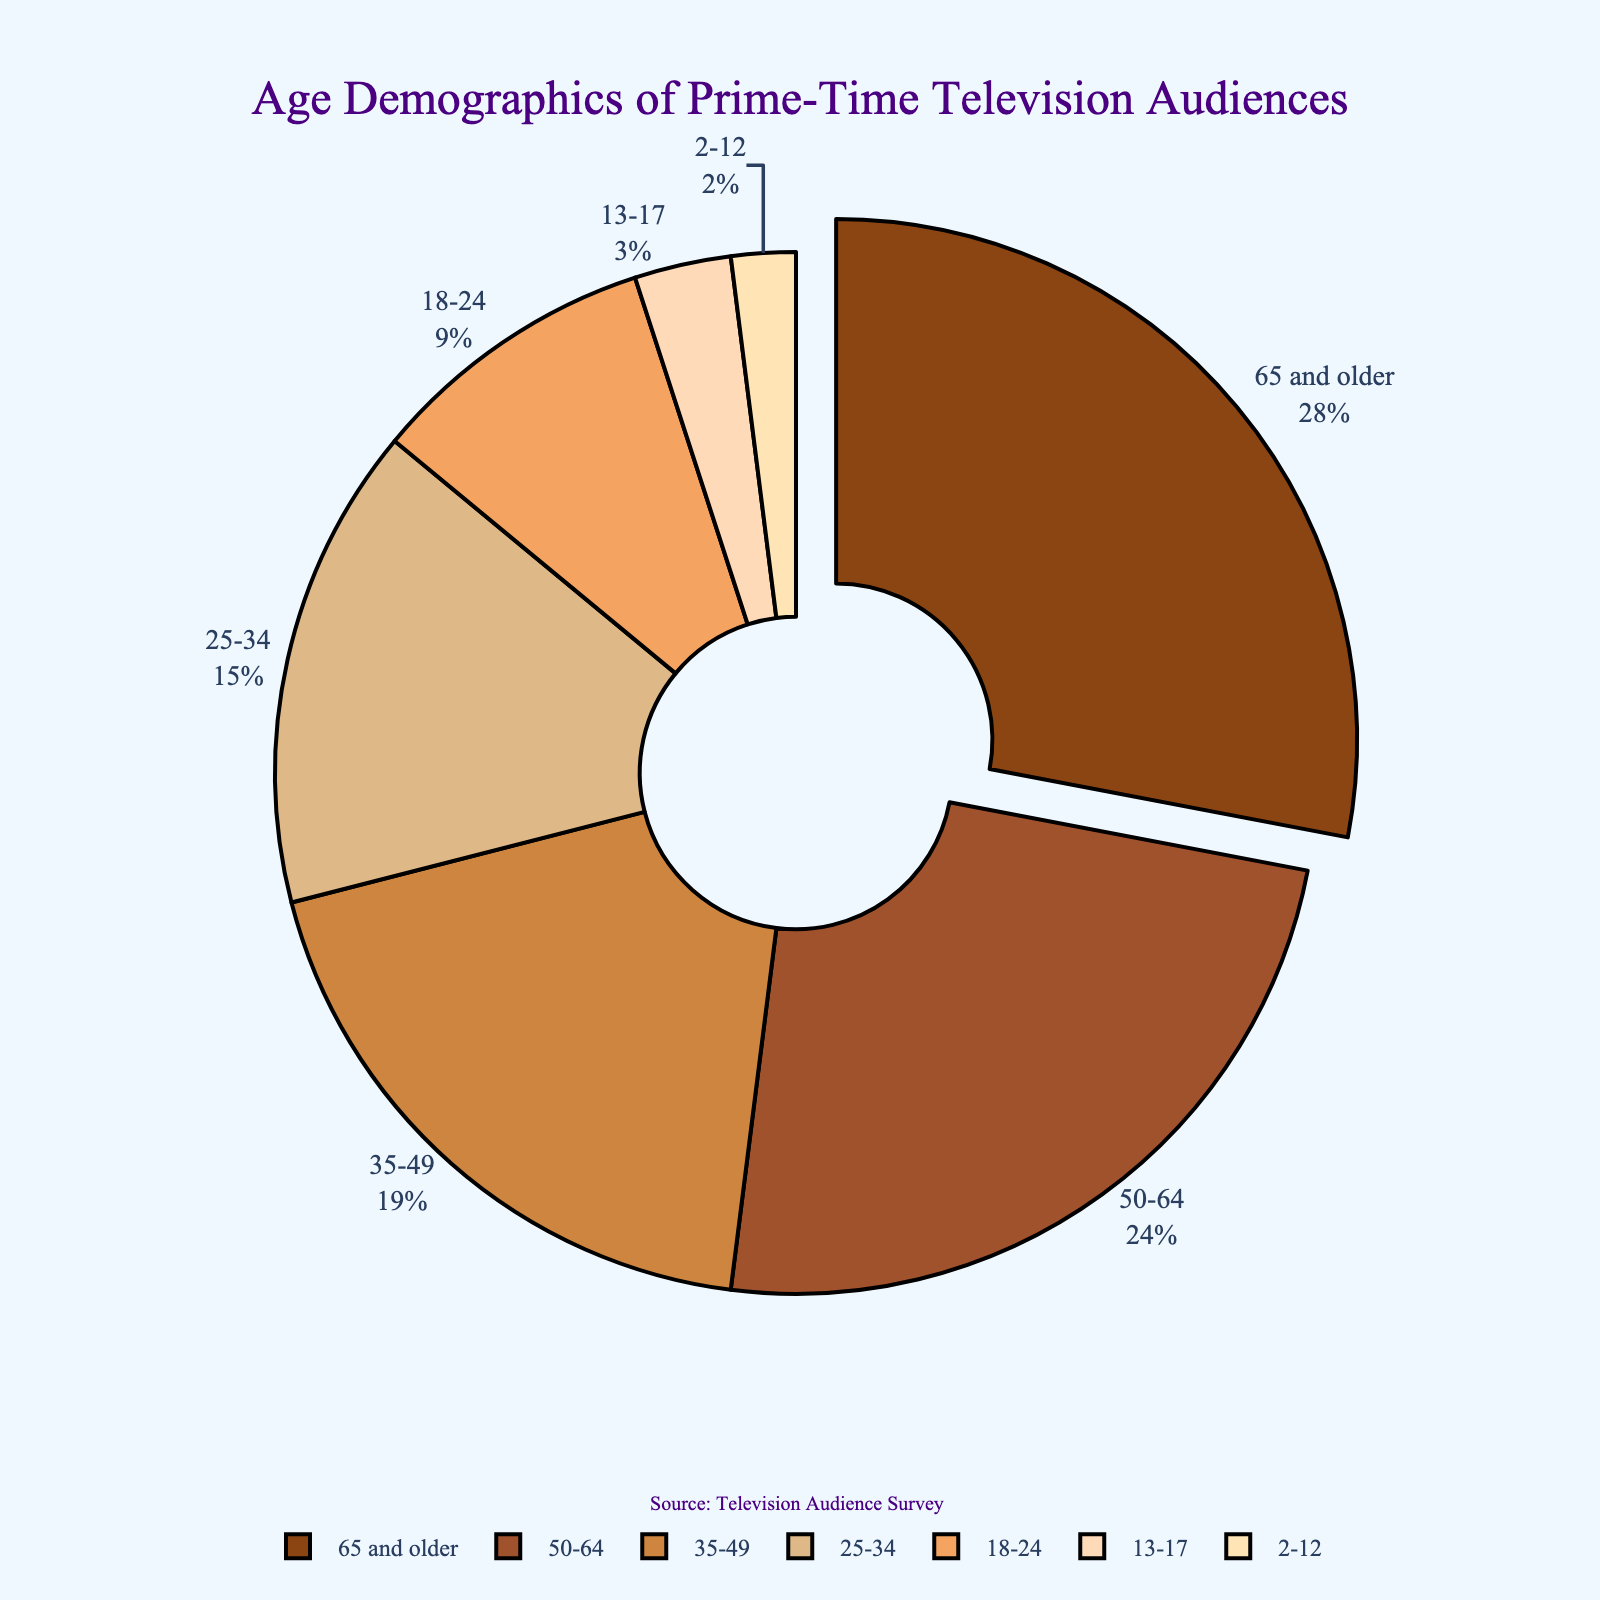What age group constitutes the largest portion of the prime-time television audience? The pie chart segment pulled out and labeled '65 and older' is the largest one, representing 28% of the total audience.
Answer: 65 and older Which two age groups combined account for over 50% of the audience? The two largest groups, '65 and older' with 28% and '50-64' with 24%, together add up to 52%.
Answer: 65 and older, 50-64 What is the total percentage of the audience aged 35 years and above? Summing the percentages for age groups '35-49' (19%), '50-64' (24%), and '65 and older' (28%), gives 19 + 24 + 28 = 71%.
Answer: 71% How does the percentage of viewers aged 18-24 compare to those aged 25-34? The 18-24 age group has 9% of the audience, while the 25-34 age group has 15%. Therefore, the 18-24 audience is smaller by 6%.
Answer: Less by 6% Which smaller age group has a higher percentage: 2-12 or 13-17? The pie chart shows the 13-17 age group at 3%, compared to the 2-12 age group at 2%. Thus, 13-17 has the higher percentage.
Answer: 13-17 What percentage of the audience is under 18 years old? Adding the percentages of the '2-12' (2%), '13-17' (3%), and '18-24' (9%) groups: 2 + 3 + 9 = 14%.
Answer: 14% Is the percentage of viewers aged 50-64 greater than those aged 35-49 and 25-34 combined? Adding the percentages for '35-49' (19%) and '25-34' (15%) gives 19 + 15 = 34%. Comparatively, the '50-64' group alone is 24%, which is less.
Answer: No What is the sum of the audience percentages for the two smallest age groups? The smallest percentages are '2-12' (2%) and '13-17' (3%). Their sum is 2 + 3 = 5%.
Answer: 5% By how much does the percentage of the '65 and older' group exceed that of the '18-24' group? The '65 and older' group is 28%, and the '18-24' group is 9%. The difference is 28 - 9 = 19%.
Answer: 19% 